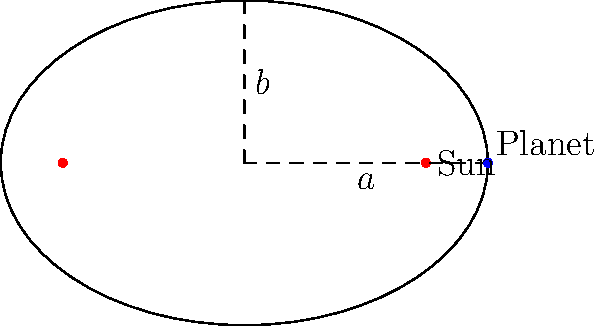In the diagram, an elliptical orbit of a planet around the Sun is shown. If the semi-major axis $a$ is 3 AU and the semi-minor axis $b$ is 2 AU, what is the distance of the Sun from the center of the ellipse (the eccentricity $e$)? To find the eccentricity of the elliptical orbit, we can follow these steps:

1) The eccentricity $e$ of an ellipse is defined as the ratio of the distance from the center to a focus (c) to the length of the semi-major axis (a):

   $$e = \frac{c}{a}$$

2) We know the semi-major axis $a = 3$ AU and the semi-minor axis $b = 2$ AU.

3) In an ellipse, $a$, $b$, and $c$ are related by the equation:

   $$a^2 = b^2 + c^2$$

4) We can rearrange this to solve for $c$:

   $$c^2 = a^2 - b^2$$
   $$c = \sqrt{a^2 - b^2}$$

5) Substituting the values:

   $$c = \sqrt{3^2 - 2^2} = \sqrt{9 - 4} = \sqrt{5}$$

6) Now we can calculate the eccentricity:

   $$e = \frac{c}{a} = \frac{\sqrt{5}}{3}$$

Therefore, the eccentricity of the orbit is $\frac{\sqrt{5}}{3}$.
Answer: $\frac{\sqrt{5}}{3}$ 